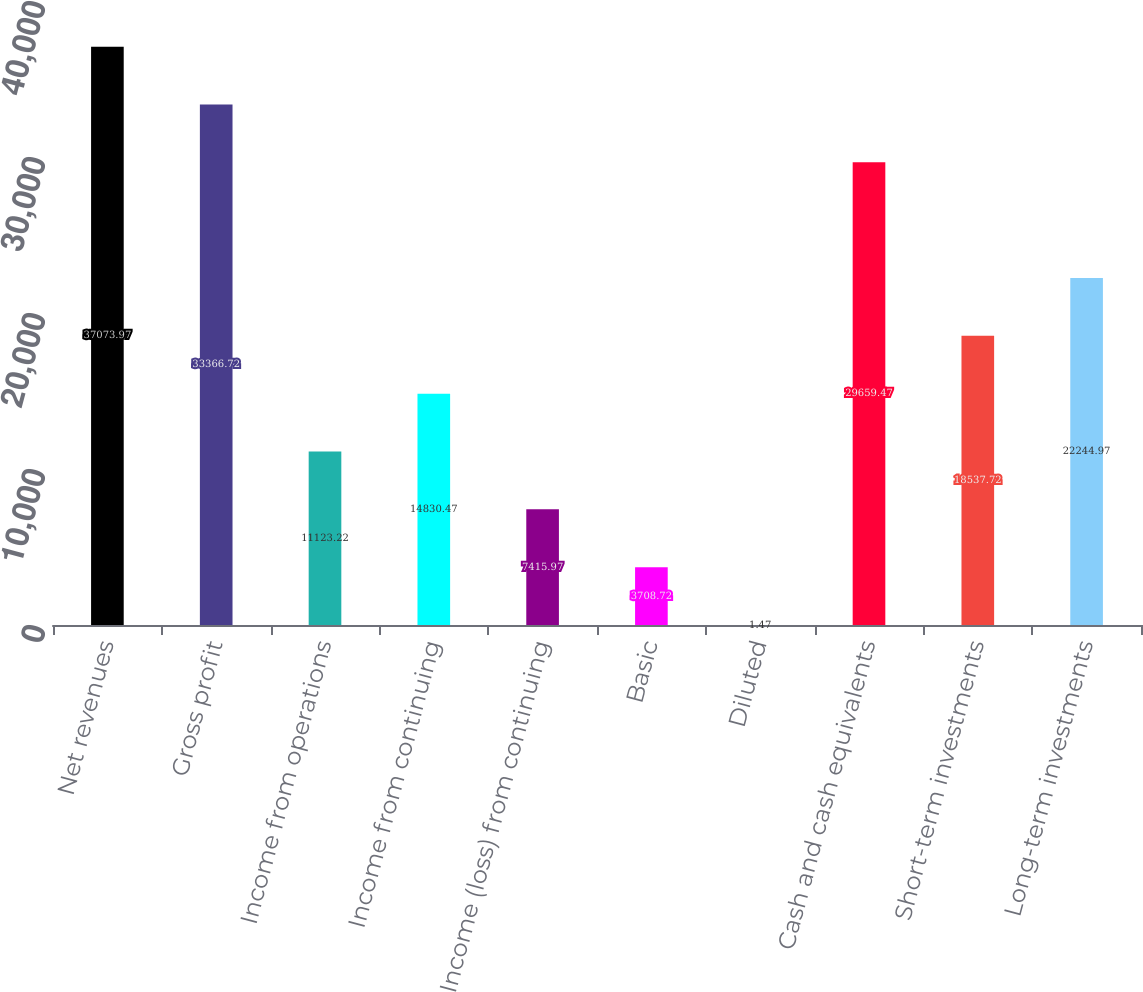Convert chart. <chart><loc_0><loc_0><loc_500><loc_500><bar_chart><fcel>Net revenues<fcel>Gross profit<fcel>Income from operations<fcel>Income from continuing<fcel>Income (loss) from continuing<fcel>Basic<fcel>Diluted<fcel>Cash and cash equivalents<fcel>Short-term investments<fcel>Long-term investments<nl><fcel>37074<fcel>33366.7<fcel>11123.2<fcel>14830.5<fcel>7415.97<fcel>3708.72<fcel>1.47<fcel>29659.5<fcel>18537.7<fcel>22245<nl></chart> 